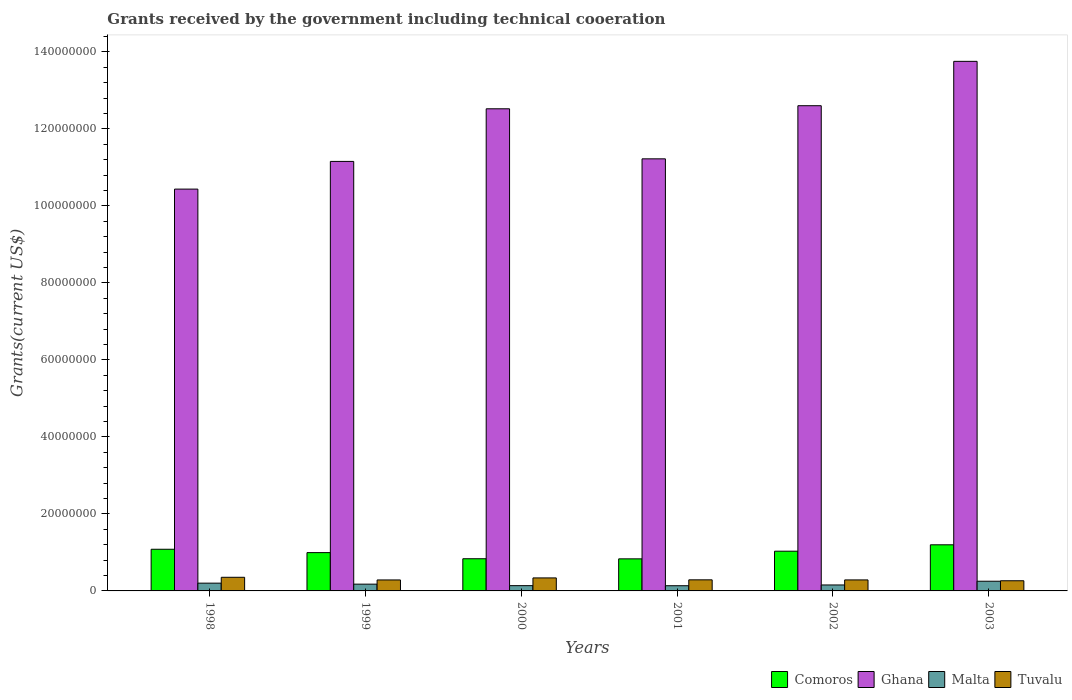How many different coloured bars are there?
Offer a very short reply. 4. How many groups of bars are there?
Ensure brevity in your answer.  6. Are the number of bars per tick equal to the number of legend labels?
Make the answer very short. Yes. How many bars are there on the 6th tick from the left?
Your response must be concise. 4. How many bars are there on the 4th tick from the right?
Give a very brief answer. 4. What is the label of the 3rd group of bars from the left?
Provide a short and direct response. 2000. In how many cases, is the number of bars for a given year not equal to the number of legend labels?
Make the answer very short. 0. What is the total grants received by the government in Comoros in 1998?
Make the answer very short. 1.08e+07. Across all years, what is the maximum total grants received by the government in Comoros?
Offer a very short reply. 1.20e+07. Across all years, what is the minimum total grants received by the government in Tuvalu?
Provide a succinct answer. 2.64e+06. What is the total total grants received by the government in Ghana in the graph?
Your answer should be very brief. 7.17e+08. What is the difference between the total grants received by the government in Tuvalu in 1998 and the total grants received by the government in Ghana in 2001?
Give a very brief answer. -1.09e+08. What is the average total grants received by the government in Comoros per year?
Your answer should be compact. 9.96e+06. In the year 1999, what is the difference between the total grants received by the government in Tuvalu and total grants received by the government in Comoros?
Your answer should be very brief. -7.10e+06. What is the ratio of the total grants received by the government in Malta in 2000 to that in 2002?
Your response must be concise. 0.88. Is the difference between the total grants received by the government in Tuvalu in 1999 and 2003 greater than the difference between the total grants received by the government in Comoros in 1999 and 2003?
Provide a succinct answer. Yes. What is the difference between the highest and the second highest total grants received by the government in Comoros?
Provide a succinct answer. 1.16e+06. In how many years, is the total grants received by the government in Ghana greater than the average total grants received by the government in Ghana taken over all years?
Your answer should be very brief. 3. Is it the case that in every year, the sum of the total grants received by the government in Ghana and total grants received by the government in Tuvalu is greater than the sum of total grants received by the government in Malta and total grants received by the government in Comoros?
Offer a terse response. Yes. What does the 1st bar from the left in 2000 represents?
Offer a very short reply. Comoros. What does the 1st bar from the right in 2003 represents?
Provide a short and direct response. Tuvalu. Is it the case that in every year, the sum of the total grants received by the government in Ghana and total grants received by the government in Tuvalu is greater than the total grants received by the government in Comoros?
Your response must be concise. Yes. What is the difference between two consecutive major ticks on the Y-axis?
Offer a very short reply. 2.00e+07. Are the values on the major ticks of Y-axis written in scientific E-notation?
Keep it short and to the point. No. Does the graph contain any zero values?
Give a very brief answer. No. Does the graph contain grids?
Keep it short and to the point. No. What is the title of the graph?
Make the answer very short. Grants received by the government including technical cooeration. Does "Niger" appear as one of the legend labels in the graph?
Keep it short and to the point. No. What is the label or title of the Y-axis?
Ensure brevity in your answer.  Grants(current US$). What is the Grants(current US$) in Comoros in 1998?
Offer a very short reply. 1.08e+07. What is the Grants(current US$) of Ghana in 1998?
Make the answer very short. 1.04e+08. What is the Grants(current US$) in Malta in 1998?
Your answer should be very brief. 2.02e+06. What is the Grants(current US$) of Tuvalu in 1998?
Ensure brevity in your answer.  3.54e+06. What is the Grants(current US$) of Comoros in 1999?
Your response must be concise. 9.95e+06. What is the Grants(current US$) of Ghana in 1999?
Ensure brevity in your answer.  1.12e+08. What is the Grants(current US$) of Malta in 1999?
Your answer should be very brief. 1.76e+06. What is the Grants(current US$) in Tuvalu in 1999?
Offer a terse response. 2.85e+06. What is the Grants(current US$) in Comoros in 2000?
Ensure brevity in your answer.  8.36e+06. What is the Grants(current US$) in Ghana in 2000?
Make the answer very short. 1.25e+08. What is the Grants(current US$) of Malta in 2000?
Your answer should be very brief. 1.37e+06. What is the Grants(current US$) in Tuvalu in 2000?
Provide a short and direct response. 3.38e+06. What is the Grants(current US$) of Comoros in 2001?
Offer a terse response. 8.33e+06. What is the Grants(current US$) in Ghana in 2001?
Keep it short and to the point. 1.12e+08. What is the Grants(current US$) in Malta in 2001?
Provide a succinct answer. 1.35e+06. What is the Grants(current US$) of Tuvalu in 2001?
Your response must be concise. 2.88e+06. What is the Grants(current US$) in Comoros in 2002?
Ensure brevity in your answer.  1.03e+07. What is the Grants(current US$) in Ghana in 2002?
Give a very brief answer. 1.26e+08. What is the Grants(current US$) of Malta in 2002?
Your answer should be very brief. 1.55e+06. What is the Grants(current US$) in Tuvalu in 2002?
Your response must be concise. 2.86e+06. What is the Grants(current US$) in Comoros in 2003?
Your response must be concise. 1.20e+07. What is the Grants(current US$) in Ghana in 2003?
Give a very brief answer. 1.38e+08. What is the Grants(current US$) of Malta in 2003?
Your answer should be compact. 2.52e+06. What is the Grants(current US$) in Tuvalu in 2003?
Your answer should be compact. 2.64e+06. Across all years, what is the maximum Grants(current US$) in Comoros?
Offer a terse response. 1.20e+07. Across all years, what is the maximum Grants(current US$) of Ghana?
Provide a succinct answer. 1.38e+08. Across all years, what is the maximum Grants(current US$) in Malta?
Ensure brevity in your answer.  2.52e+06. Across all years, what is the maximum Grants(current US$) in Tuvalu?
Offer a terse response. 3.54e+06. Across all years, what is the minimum Grants(current US$) in Comoros?
Make the answer very short. 8.33e+06. Across all years, what is the minimum Grants(current US$) in Ghana?
Keep it short and to the point. 1.04e+08. Across all years, what is the minimum Grants(current US$) of Malta?
Offer a very short reply. 1.35e+06. Across all years, what is the minimum Grants(current US$) of Tuvalu?
Provide a short and direct response. 2.64e+06. What is the total Grants(current US$) of Comoros in the graph?
Offer a very short reply. 5.98e+07. What is the total Grants(current US$) of Ghana in the graph?
Provide a succinct answer. 7.17e+08. What is the total Grants(current US$) in Malta in the graph?
Give a very brief answer. 1.06e+07. What is the total Grants(current US$) in Tuvalu in the graph?
Make the answer very short. 1.82e+07. What is the difference between the Grants(current US$) in Comoros in 1998 and that in 1999?
Ensure brevity in your answer.  8.70e+05. What is the difference between the Grants(current US$) of Ghana in 1998 and that in 1999?
Provide a short and direct response. -7.19e+06. What is the difference between the Grants(current US$) in Malta in 1998 and that in 1999?
Make the answer very short. 2.60e+05. What is the difference between the Grants(current US$) in Tuvalu in 1998 and that in 1999?
Your response must be concise. 6.90e+05. What is the difference between the Grants(current US$) in Comoros in 1998 and that in 2000?
Provide a short and direct response. 2.46e+06. What is the difference between the Grants(current US$) of Ghana in 1998 and that in 2000?
Offer a terse response. -2.09e+07. What is the difference between the Grants(current US$) in Malta in 1998 and that in 2000?
Keep it short and to the point. 6.50e+05. What is the difference between the Grants(current US$) of Comoros in 1998 and that in 2001?
Your answer should be compact. 2.49e+06. What is the difference between the Grants(current US$) of Ghana in 1998 and that in 2001?
Your answer should be very brief. -7.86e+06. What is the difference between the Grants(current US$) in Malta in 1998 and that in 2001?
Ensure brevity in your answer.  6.70e+05. What is the difference between the Grants(current US$) of Comoros in 1998 and that in 2002?
Your answer should be compact. 5.00e+05. What is the difference between the Grants(current US$) in Ghana in 1998 and that in 2002?
Your answer should be compact. -2.17e+07. What is the difference between the Grants(current US$) in Tuvalu in 1998 and that in 2002?
Keep it short and to the point. 6.80e+05. What is the difference between the Grants(current US$) in Comoros in 1998 and that in 2003?
Your answer should be compact. -1.16e+06. What is the difference between the Grants(current US$) of Ghana in 1998 and that in 2003?
Offer a very short reply. -3.32e+07. What is the difference between the Grants(current US$) of Malta in 1998 and that in 2003?
Offer a terse response. -5.00e+05. What is the difference between the Grants(current US$) in Tuvalu in 1998 and that in 2003?
Give a very brief answer. 9.00e+05. What is the difference between the Grants(current US$) of Comoros in 1999 and that in 2000?
Your answer should be compact. 1.59e+06. What is the difference between the Grants(current US$) in Ghana in 1999 and that in 2000?
Ensure brevity in your answer.  -1.37e+07. What is the difference between the Grants(current US$) in Tuvalu in 1999 and that in 2000?
Offer a very short reply. -5.30e+05. What is the difference between the Grants(current US$) in Comoros in 1999 and that in 2001?
Your answer should be very brief. 1.62e+06. What is the difference between the Grants(current US$) of Ghana in 1999 and that in 2001?
Offer a very short reply. -6.70e+05. What is the difference between the Grants(current US$) in Tuvalu in 1999 and that in 2001?
Provide a succinct answer. -3.00e+04. What is the difference between the Grants(current US$) in Comoros in 1999 and that in 2002?
Offer a very short reply. -3.70e+05. What is the difference between the Grants(current US$) in Ghana in 1999 and that in 2002?
Your answer should be compact. -1.45e+07. What is the difference between the Grants(current US$) in Tuvalu in 1999 and that in 2002?
Make the answer very short. -10000. What is the difference between the Grants(current US$) of Comoros in 1999 and that in 2003?
Your answer should be very brief. -2.03e+06. What is the difference between the Grants(current US$) of Ghana in 1999 and that in 2003?
Ensure brevity in your answer.  -2.60e+07. What is the difference between the Grants(current US$) in Malta in 1999 and that in 2003?
Offer a terse response. -7.60e+05. What is the difference between the Grants(current US$) in Tuvalu in 1999 and that in 2003?
Provide a succinct answer. 2.10e+05. What is the difference between the Grants(current US$) of Ghana in 2000 and that in 2001?
Provide a succinct answer. 1.30e+07. What is the difference between the Grants(current US$) of Malta in 2000 and that in 2001?
Give a very brief answer. 2.00e+04. What is the difference between the Grants(current US$) in Comoros in 2000 and that in 2002?
Your answer should be compact. -1.96e+06. What is the difference between the Grants(current US$) of Ghana in 2000 and that in 2002?
Provide a succinct answer. -8.00e+05. What is the difference between the Grants(current US$) in Tuvalu in 2000 and that in 2002?
Offer a very short reply. 5.20e+05. What is the difference between the Grants(current US$) in Comoros in 2000 and that in 2003?
Give a very brief answer. -3.62e+06. What is the difference between the Grants(current US$) in Ghana in 2000 and that in 2003?
Provide a short and direct response. -1.23e+07. What is the difference between the Grants(current US$) in Malta in 2000 and that in 2003?
Your response must be concise. -1.15e+06. What is the difference between the Grants(current US$) of Tuvalu in 2000 and that in 2003?
Provide a succinct answer. 7.40e+05. What is the difference between the Grants(current US$) in Comoros in 2001 and that in 2002?
Give a very brief answer. -1.99e+06. What is the difference between the Grants(current US$) of Ghana in 2001 and that in 2002?
Ensure brevity in your answer.  -1.38e+07. What is the difference between the Grants(current US$) of Tuvalu in 2001 and that in 2002?
Provide a succinct answer. 2.00e+04. What is the difference between the Grants(current US$) of Comoros in 2001 and that in 2003?
Keep it short and to the point. -3.65e+06. What is the difference between the Grants(current US$) of Ghana in 2001 and that in 2003?
Give a very brief answer. -2.53e+07. What is the difference between the Grants(current US$) in Malta in 2001 and that in 2003?
Offer a terse response. -1.17e+06. What is the difference between the Grants(current US$) in Comoros in 2002 and that in 2003?
Offer a terse response. -1.66e+06. What is the difference between the Grants(current US$) in Ghana in 2002 and that in 2003?
Your answer should be very brief. -1.15e+07. What is the difference between the Grants(current US$) of Malta in 2002 and that in 2003?
Provide a short and direct response. -9.70e+05. What is the difference between the Grants(current US$) of Comoros in 1998 and the Grants(current US$) of Ghana in 1999?
Your response must be concise. -1.01e+08. What is the difference between the Grants(current US$) of Comoros in 1998 and the Grants(current US$) of Malta in 1999?
Offer a very short reply. 9.06e+06. What is the difference between the Grants(current US$) of Comoros in 1998 and the Grants(current US$) of Tuvalu in 1999?
Give a very brief answer. 7.97e+06. What is the difference between the Grants(current US$) of Ghana in 1998 and the Grants(current US$) of Malta in 1999?
Your answer should be very brief. 1.03e+08. What is the difference between the Grants(current US$) of Ghana in 1998 and the Grants(current US$) of Tuvalu in 1999?
Provide a short and direct response. 1.02e+08. What is the difference between the Grants(current US$) of Malta in 1998 and the Grants(current US$) of Tuvalu in 1999?
Offer a terse response. -8.30e+05. What is the difference between the Grants(current US$) in Comoros in 1998 and the Grants(current US$) in Ghana in 2000?
Make the answer very short. -1.14e+08. What is the difference between the Grants(current US$) in Comoros in 1998 and the Grants(current US$) in Malta in 2000?
Provide a short and direct response. 9.45e+06. What is the difference between the Grants(current US$) of Comoros in 1998 and the Grants(current US$) of Tuvalu in 2000?
Your answer should be compact. 7.44e+06. What is the difference between the Grants(current US$) of Ghana in 1998 and the Grants(current US$) of Malta in 2000?
Provide a succinct answer. 1.03e+08. What is the difference between the Grants(current US$) of Ghana in 1998 and the Grants(current US$) of Tuvalu in 2000?
Your answer should be compact. 1.01e+08. What is the difference between the Grants(current US$) of Malta in 1998 and the Grants(current US$) of Tuvalu in 2000?
Your answer should be compact. -1.36e+06. What is the difference between the Grants(current US$) of Comoros in 1998 and the Grants(current US$) of Ghana in 2001?
Offer a terse response. -1.01e+08. What is the difference between the Grants(current US$) in Comoros in 1998 and the Grants(current US$) in Malta in 2001?
Give a very brief answer. 9.47e+06. What is the difference between the Grants(current US$) in Comoros in 1998 and the Grants(current US$) in Tuvalu in 2001?
Offer a terse response. 7.94e+06. What is the difference between the Grants(current US$) in Ghana in 1998 and the Grants(current US$) in Malta in 2001?
Offer a terse response. 1.03e+08. What is the difference between the Grants(current US$) in Ghana in 1998 and the Grants(current US$) in Tuvalu in 2001?
Your answer should be compact. 1.01e+08. What is the difference between the Grants(current US$) in Malta in 1998 and the Grants(current US$) in Tuvalu in 2001?
Your answer should be very brief. -8.60e+05. What is the difference between the Grants(current US$) of Comoros in 1998 and the Grants(current US$) of Ghana in 2002?
Provide a succinct answer. -1.15e+08. What is the difference between the Grants(current US$) in Comoros in 1998 and the Grants(current US$) in Malta in 2002?
Make the answer very short. 9.27e+06. What is the difference between the Grants(current US$) in Comoros in 1998 and the Grants(current US$) in Tuvalu in 2002?
Your response must be concise. 7.96e+06. What is the difference between the Grants(current US$) of Ghana in 1998 and the Grants(current US$) of Malta in 2002?
Provide a succinct answer. 1.03e+08. What is the difference between the Grants(current US$) in Ghana in 1998 and the Grants(current US$) in Tuvalu in 2002?
Your answer should be compact. 1.02e+08. What is the difference between the Grants(current US$) in Malta in 1998 and the Grants(current US$) in Tuvalu in 2002?
Provide a short and direct response. -8.40e+05. What is the difference between the Grants(current US$) in Comoros in 1998 and the Grants(current US$) in Ghana in 2003?
Give a very brief answer. -1.27e+08. What is the difference between the Grants(current US$) of Comoros in 1998 and the Grants(current US$) of Malta in 2003?
Your answer should be very brief. 8.30e+06. What is the difference between the Grants(current US$) in Comoros in 1998 and the Grants(current US$) in Tuvalu in 2003?
Make the answer very short. 8.18e+06. What is the difference between the Grants(current US$) in Ghana in 1998 and the Grants(current US$) in Malta in 2003?
Offer a terse response. 1.02e+08. What is the difference between the Grants(current US$) of Ghana in 1998 and the Grants(current US$) of Tuvalu in 2003?
Ensure brevity in your answer.  1.02e+08. What is the difference between the Grants(current US$) in Malta in 1998 and the Grants(current US$) in Tuvalu in 2003?
Provide a succinct answer. -6.20e+05. What is the difference between the Grants(current US$) in Comoros in 1999 and the Grants(current US$) in Ghana in 2000?
Offer a very short reply. -1.15e+08. What is the difference between the Grants(current US$) of Comoros in 1999 and the Grants(current US$) of Malta in 2000?
Your answer should be compact. 8.58e+06. What is the difference between the Grants(current US$) in Comoros in 1999 and the Grants(current US$) in Tuvalu in 2000?
Offer a very short reply. 6.57e+06. What is the difference between the Grants(current US$) of Ghana in 1999 and the Grants(current US$) of Malta in 2000?
Provide a succinct answer. 1.10e+08. What is the difference between the Grants(current US$) of Ghana in 1999 and the Grants(current US$) of Tuvalu in 2000?
Give a very brief answer. 1.08e+08. What is the difference between the Grants(current US$) of Malta in 1999 and the Grants(current US$) of Tuvalu in 2000?
Provide a succinct answer. -1.62e+06. What is the difference between the Grants(current US$) in Comoros in 1999 and the Grants(current US$) in Ghana in 2001?
Give a very brief answer. -1.02e+08. What is the difference between the Grants(current US$) of Comoros in 1999 and the Grants(current US$) of Malta in 2001?
Provide a succinct answer. 8.60e+06. What is the difference between the Grants(current US$) in Comoros in 1999 and the Grants(current US$) in Tuvalu in 2001?
Your response must be concise. 7.07e+06. What is the difference between the Grants(current US$) in Ghana in 1999 and the Grants(current US$) in Malta in 2001?
Offer a very short reply. 1.10e+08. What is the difference between the Grants(current US$) of Ghana in 1999 and the Grants(current US$) of Tuvalu in 2001?
Your response must be concise. 1.09e+08. What is the difference between the Grants(current US$) of Malta in 1999 and the Grants(current US$) of Tuvalu in 2001?
Provide a short and direct response. -1.12e+06. What is the difference between the Grants(current US$) of Comoros in 1999 and the Grants(current US$) of Ghana in 2002?
Your answer should be compact. -1.16e+08. What is the difference between the Grants(current US$) of Comoros in 1999 and the Grants(current US$) of Malta in 2002?
Offer a terse response. 8.40e+06. What is the difference between the Grants(current US$) in Comoros in 1999 and the Grants(current US$) in Tuvalu in 2002?
Your answer should be very brief. 7.09e+06. What is the difference between the Grants(current US$) in Ghana in 1999 and the Grants(current US$) in Malta in 2002?
Your answer should be compact. 1.10e+08. What is the difference between the Grants(current US$) of Ghana in 1999 and the Grants(current US$) of Tuvalu in 2002?
Provide a short and direct response. 1.09e+08. What is the difference between the Grants(current US$) of Malta in 1999 and the Grants(current US$) of Tuvalu in 2002?
Offer a terse response. -1.10e+06. What is the difference between the Grants(current US$) of Comoros in 1999 and the Grants(current US$) of Ghana in 2003?
Ensure brevity in your answer.  -1.28e+08. What is the difference between the Grants(current US$) of Comoros in 1999 and the Grants(current US$) of Malta in 2003?
Offer a terse response. 7.43e+06. What is the difference between the Grants(current US$) of Comoros in 1999 and the Grants(current US$) of Tuvalu in 2003?
Ensure brevity in your answer.  7.31e+06. What is the difference between the Grants(current US$) in Ghana in 1999 and the Grants(current US$) in Malta in 2003?
Keep it short and to the point. 1.09e+08. What is the difference between the Grants(current US$) in Ghana in 1999 and the Grants(current US$) in Tuvalu in 2003?
Offer a very short reply. 1.09e+08. What is the difference between the Grants(current US$) of Malta in 1999 and the Grants(current US$) of Tuvalu in 2003?
Provide a succinct answer. -8.80e+05. What is the difference between the Grants(current US$) of Comoros in 2000 and the Grants(current US$) of Ghana in 2001?
Your answer should be compact. -1.04e+08. What is the difference between the Grants(current US$) of Comoros in 2000 and the Grants(current US$) of Malta in 2001?
Ensure brevity in your answer.  7.01e+06. What is the difference between the Grants(current US$) of Comoros in 2000 and the Grants(current US$) of Tuvalu in 2001?
Your response must be concise. 5.48e+06. What is the difference between the Grants(current US$) in Ghana in 2000 and the Grants(current US$) in Malta in 2001?
Offer a very short reply. 1.24e+08. What is the difference between the Grants(current US$) of Ghana in 2000 and the Grants(current US$) of Tuvalu in 2001?
Provide a short and direct response. 1.22e+08. What is the difference between the Grants(current US$) of Malta in 2000 and the Grants(current US$) of Tuvalu in 2001?
Provide a succinct answer. -1.51e+06. What is the difference between the Grants(current US$) in Comoros in 2000 and the Grants(current US$) in Ghana in 2002?
Give a very brief answer. -1.18e+08. What is the difference between the Grants(current US$) in Comoros in 2000 and the Grants(current US$) in Malta in 2002?
Make the answer very short. 6.81e+06. What is the difference between the Grants(current US$) of Comoros in 2000 and the Grants(current US$) of Tuvalu in 2002?
Ensure brevity in your answer.  5.50e+06. What is the difference between the Grants(current US$) in Ghana in 2000 and the Grants(current US$) in Malta in 2002?
Provide a short and direct response. 1.24e+08. What is the difference between the Grants(current US$) in Ghana in 2000 and the Grants(current US$) in Tuvalu in 2002?
Offer a very short reply. 1.22e+08. What is the difference between the Grants(current US$) of Malta in 2000 and the Grants(current US$) of Tuvalu in 2002?
Your answer should be very brief. -1.49e+06. What is the difference between the Grants(current US$) of Comoros in 2000 and the Grants(current US$) of Ghana in 2003?
Your answer should be very brief. -1.29e+08. What is the difference between the Grants(current US$) in Comoros in 2000 and the Grants(current US$) in Malta in 2003?
Your answer should be compact. 5.84e+06. What is the difference between the Grants(current US$) of Comoros in 2000 and the Grants(current US$) of Tuvalu in 2003?
Provide a short and direct response. 5.72e+06. What is the difference between the Grants(current US$) of Ghana in 2000 and the Grants(current US$) of Malta in 2003?
Give a very brief answer. 1.23e+08. What is the difference between the Grants(current US$) of Ghana in 2000 and the Grants(current US$) of Tuvalu in 2003?
Provide a succinct answer. 1.23e+08. What is the difference between the Grants(current US$) of Malta in 2000 and the Grants(current US$) of Tuvalu in 2003?
Give a very brief answer. -1.27e+06. What is the difference between the Grants(current US$) in Comoros in 2001 and the Grants(current US$) in Ghana in 2002?
Offer a terse response. -1.18e+08. What is the difference between the Grants(current US$) in Comoros in 2001 and the Grants(current US$) in Malta in 2002?
Your answer should be very brief. 6.78e+06. What is the difference between the Grants(current US$) in Comoros in 2001 and the Grants(current US$) in Tuvalu in 2002?
Offer a terse response. 5.47e+06. What is the difference between the Grants(current US$) of Ghana in 2001 and the Grants(current US$) of Malta in 2002?
Your answer should be very brief. 1.11e+08. What is the difference between the Grants(current US$) of Ghana in 2001 and the Grants(current US$) of Tuvalu in 2002?
Give a very brief answer. 1.09e+08. What is the difference between the Grants(current US$) of Malta in 2001 and the Grants(current US$) of Tuvalu in 2002?
Your answer should be very brief. -1.51e+06. What is the difference between the Grants(current US$) in Comoros in 2001 and the Grants(current US$) in Ghana in 2003?
Provide a succinct answer. -1.29e+08. What is the difference between the Grants(current US$) of Comoros in 2001 and the Grants(current US$) of Malta in 2003?
Your response must be concise. 5.81e+06. What is the difference between the Grants(current US$) in Comoros in 2001 and the Grants(current US$) in Tuvalu in 2003?
Offer a terse response. 5.69e+06. What is the difference between the Grants(current US$) of Ghana in 2001 and the Grants(current US$) of Malta in 2003?
Your answer should be very brief. 1.10e+08. What is the difference between the Grants(current US$) in Ghana in 2001 and the Grants(current US$) in Tuvalu in 2003?
Provide a short and direct response. 1.10e+08. What is the difference between the Grants(current US$) of Malta in 2001 and the Grants(current US$) of Tuvalu in 2003?
Make the answer very short. -1.29e+06. What is the difference between the Grants(current US$) of Comoros in 2002 and the Grants(current US$) of Ghana in 2003?
Provide a short and direct response. -1.27e+08. What is the difference between the Grants(current US$) in Comoros in 2002 and the Grants(current US$) in Malta in 2003?
Keep it short and to the point. 7.80e+06. What is the difference between the Grants(current US$) of Comoros in 2002 and the Grants(current US$) of Tuvalu in 2003?
Ensure brevity in your answer.  7.68e+06. What is the difference between the Grants(current US$) in Ghana in 2002 and the Grants(current US$) in Malta in 2003?
Make the answer very short. 1.24e+08. What is the difference between the Grants(current US$) of Ghana in 2002 and the Grants(current US$) of Tuvalu in 2003?
Provide a short and direct response. 1.23e+08. What is the difference between the Grants(current US$) in Malta in 2002 and the Grants(current US$) in Tuvalu in 2003?
Ensure brevity in your answer.  -1.09e+06. What is the average Grants(current US$) of Comoros per year?
Offer a terse response. 9.96e+06. What is the average Grants(current US$) of Ghana per year?
Give a very brief answer. 1.19e+08. What is the average Grants(current US$) of Malta per year?
Keep it short and to the point. 1.76e+06. What is the average Grants(current US$) of Tuvalu per year?
Your response must be concise. 3.02e+06. In the year 1998, what is the difference between the Grants(current US$) of Comoros and Grants(current US$) of Ghana?
Make the answer very short. -9.36e+07. In the year 1998, what is the difference between the Grants(current US$) in Comoros and Grants(current US$) in Malta?
Keep it short and to the point. 8.80e+06. In the year 1998, what is the difference between the Grants(current US$) in Comoros and Grants(current US$) in Tuvalu?
Your response must be concise. 7.28e+06. In the year 1998, what is the difference between the Grants(current US$) of Ghana and Grants(current US$) of Malta?
Ensure brevity in your answer.  1.02e+08. In the year 1998, what is the difference between the Grants(current US$) of Ghana and Grants(current US$) of Tuvalu?
Make the answer very short. 1.01e+08. In the year 1998, what is the difference between the Grants(current US$) of Malta and Grants(current US$) of Tuvalu?
Your response must be concise. -1.52e+06. In the year 1999, what is the difference between the Grants(current US$) of Comoros and Grants(current US$) of Ghana?
Make the answer very short. -1.02e+08. In the year 1999, what is the difference between the Grants(current US$) of Comoros and Grants(current US$) of Malta?
Provide a short and direct response. 8.19e+06. In the year 1999, what is the difference between the Grants(current US$) of Comoros and Grants(current US$) of Tuvalu?
Keep it short and to the point. 7.10e+06. In the year 1999, what is the difference between the Grants(current US$) of Ghana and Grants(current US$) of Malta?
Provide a short and direct response. 1.10e+08. In the year 1999, what is the difference between the Grants(current US$) of Ghana and Grants(current US$) of Tuvalu?
Offer a very short reply. 1.09e+08. In the year 1999, what is the difference between the Grants(current US$) in Malta and Grants(current US$) in Tuvalu?
Your answer should be compact. -1.09e+06. In the year 2000, what is the difference between the Grants(current US$) of Comoros and Grants(current US$) of Ghana?
Give a very brief answer. -1.17e+08. In the year 2000, what is the difference between the Grants(current US$) of Comoros and Grants(current US$) of Malta?
Provide a succinct answer. 6.99e+06. In the year 2000, what is the difference between the Grants(current US$) of Comoros and Grants(current US$) of Tuvalu?
Your response must be concise. 4.98e+06. In the year 2000, what is the difference between the Grants(current US$) of Ghana and Grants(current US$) of Malta?
Your response must be concise. 1.24e+08. In the year 2000, what is the difference between the Grants(current US$) of Ghana and Grants(current US$) of Tuvalu?
Make the answer very short. 1.22e+08. In the year 2000, what is the difference between the Grants(current US$) of Malta and Grants(current US$) of Tuvalu?
Offer a terse response. -2.01e+06. In the year 2001, what is the difference between the Grants(current US$) in Comoros and Grants(current US$) in Ghana?
Offer a terse response. -1.04e+08. In the year 2001, what is the difference between the Grants(current US$) in Comoros and Grants(current US$) in Malta?
Your answer should be compact. 6.98e+06. In the year 2001, what is the difference between the Grants(current US$) in Comoros and Grants(current US$) in Tuvalu?
Provide a short and direct response. 5.45e+06. In the year 2001, what is the difference between the Grants(current US$) in Ghana and Grants(current US$) in Malta?
Offer a terse response. 1.11e+08. In the year 2001, what is the difference between the Grants(current US$) of Ghana and Grants(current US$) of Tuvalu?
Provide a succinct answer. 1.09e+08. In the year 2001, what is the difference between the Grants(current US$) of Malta and Grants(current US$) of Tuvalu?
Your answer should be compact. -1.53e+06. In the year 2002, what is the difference between the Grants(current US$) of Comoros and Grants(current US$) of Ghana?
Your response must be concise. -1.16e+08. In the year 2002, what is the difference between the Grants(current US$) in Comoros and Grants(current US$) in Malta?
Provide a succinct answer. 8.77e+06. In the year 2002, what is the difference between the Grants(current US$) of Comoros and Grants(current US$) of Tuvalu?
Make the answer very short. 7.46e+06. In the year 2002, what is the difference between the Grants(current US$) in Ghana and Grants(current US$) in Malta?
Offer a very short reply. 1.24e+08. In the year 2002, what is the difference between the Grants(current US$) of Ghana and Grants(current US$) of Tuvalu?
Offer a terse response. 1.23e+08. In the year 2002, what is the difference between the Grants(current US$) of Malta and Grants(current US$) of Tuvalu?
Ensure brevity in your answer.  -1.31e+06. In the year 2003, what is the difference between the Grants(current US$) in Comoros and Grants(current US$) in Ghana?
Offer a terse response. -1.26e+08. In the year 2003, what is the difference between the Grants(current US$) in Comoros and Grants(current US$) in Malta?
Provide a succinct answer. 9.46e+06. In the year 2003, what is the difference between the Grants(current US$) in Comoros and Grants(current US$) in Tuvalu?
Give a very brief answer. 9.34e+06. In the year 2003, what is the difference between the Grants(current US$) of Ghana and Grants(current US$) of Malta?
Ensure brevity in your answer.  1.35e+08. In the year 2003, what is the difference between the Grants(current US$) of Ghana and Grants(current US$) of Tuvalu?
Make the answer very short. 1.35e+08. In the year 2003, what is the difference between the Grants(current US$) of Malta and Grants(current US$) of Tuvalu?
Your answer should be very brief. -1.20e+05. What is the ratio of the Grants(current US$) of Comoros in 1998 to that in 1999?
Your response must be concise. 1.09. What is the ratio of the Grants(current US$) of Ghana in 1998 to that in 1999?
Provide a short and direct response. 0.94. What is the ratio of the Grants(current US$) of Malta in 1998 to that in 1999?
Provide a short and direct response. 1.15. What is the ratio of the Grants(current US$) of Tuvalu in 1998 to that in 1999?
Give a very brief answer. 1.24. What is the ratio of the Grants(current US$) of Comoros in 1998 to that in 2000?
Ensure brevity in your answer.  1.29. What is the ratio of the Grants(current US$) in Ghana in 1998 to that in 2000?
Provide a succinct answer. 0.83. What is the ratio of the Grants(current US$) in Malta in 1998 to that in 2000?
Provide a short and direct response. 1.47. What is the ratio of the Grants(current US$) in Tuvalu in 1998 to that in 2000?
Make the answer very short. 1.05. What is the ratio of the Grants(current US$) in Comoros in 1998 to that in 2001?
Make the answer very short. 1.3. What is the ratio of the Grants(current US$) in Ghana in 1998 to that in 2001?
Your response must be concise. 0.93. What is the ratio of the Grants(current US$) in Malta in 1998 to that in 2001?
Your response must be concise. 1.5. What is the ratio of the Grants(current US$) of Tuvalu in 1998 to that in 2001?
Offer a very short reply. 1.23. What is the ratio of the Grants(current US$) of Comoros in 1998 to that in 2002?
Offer a terse response. 1.05. What is the ratio of the Grants(current US$) in Ghana in 1998 to that in 2002?
Your answer should be very brief. 0.83. What is the ratio of the Grants(current US$) in Malta in 1998 to that in 2002?
Your answer should be compact. 1.3. What is the ratio of the Grants(current US$) in Tuvalu in 1998 to that in 2002?
Your answer should be very brief. 1.24. What is the ratio of the Grants(current US$) in Comoros in 1998 to that in 2003?
Give a very brief answer. 0.9. What is the ratio of the Grants(current US$) in Ghana in 1998 to that in 2003?
Offer a terse response. 0.76. What is the ratio of the Grants(current US$) of Malta in 1998 to that in 2003?
Provide a short and direct response. 0.8. What is the ratio of the Grants(current US$) of Tuvalu in 1998 to that in 2003?
Offer a terse response. 1.34. What is the ratio of the Grants(current US$) in Comoros in 1999 to that in 2000?
Make the answer very short. 1.19. What is the ratio of the Grants(current US$) in Ghana in 1999 to that in 2000?
Your answer should be very brief. 0.89. What is the ratio of the Grants(current US$) in Malta in 1999 to that in 2000?
Make the answer very short. 1.28. What is the ratio of the Grants(current US$) in Tuvalu in 1999 to that in 2000?
Provide a short and direct response. 0.84. What is the ratio of the Grants(current US$) in Comoros in 1999 to that in 2001?
Keep it short and to the point. 1.19. What is the ratio of the Grants(current US$) of Ghana in 1999 to that in 2001?
Provide a succinct answer. 0.99. What is the ratio of the Grants(current US$) of Malta in 1999 to that in 2001?
Provide a short and direct response. 1.3. What is the ratio of the Grants(current US$) of Tuvalu in 1999 to that in 2001?
Provide a short and direct response. 0.99. What is the ratio of the Grants(current US$) in Comoros in 1999 to that in 2002?
Ensure brevity in your answer.  0.96. What is the ratio of the Grants(current US$) of Ghana in 1999 to that in 2002?
Make the answer very short. 0.89. What is the ratio of the Grants(current US$) in Malta in 1999 to that in 2002?
Offer a terse response. 1.14. What is the ratio of the Grants(current US$) of Comoros in 1999 to that in 2003?
Offer a terse response. 0.83. What is the ratio of the Grants(current US$) in Ghana in 1999 to that in 2003?
Ensure brevity in your answer.  0.81. What is the ratio of the Grants(current US$) of Malta in 1999 to that in 2003?
Your answer should be compact. 0.7. What is the ratio of the Grants(current US$) in Tuvalu in 1999 to that in 2003?
Make the answer very short. 1.08. What is the ratio of the Grants(current US$) in Ghana in 2000 to that in 2001?
Your response must be concise. 1.12. What is the ratio of the Grants(current US$) in Malta in 2000 to that in 2001?
Your answer should be compact. 1.01. What is the ratio of the Grants(current US$) of Tuvalu in 2000 to that in 2001?
Give a very brief answer. 1.17. What is the ratio of the Grants(current US$) of Comoros in 2000 to that in 2002?
Give a very brief answer. 0.81. What is the ratio of the Grants(current US$) of Malta in 2000 to that in 2002?
Your response must be concise. 0.88. What is the ratio of the Grants(current US$) in Tuvalu in 2000 to that in 2002?
Provide a short and direct response. 1.18. What is the ratio of the Grants(current US$) of Comoros in 2000 to that in 2003?
Offer a very short reply. 0.7. What is the ratio of the Grants(current US$) of Ghana in 2000 to that in 2003?
Your answer should be very brief. 0.91. What is the ratio of the Grants(current US$) in Malta in 2000 to that in 2003?
Your answer should be compact. 0.54. What is the ratio of the Grants(current US$) of Tuvalu in 2000 to that in 2003?
Provide a short and direct response. 1.28. What is the ratio of the Grants(current US$) of Comoros in 2001 to that in 2002?
Ensure brevity in your answer.  0.81. What is the ratio of the Grants(current US$) in Ghana in 2001 to that in 2002?
Provide a short and direct response. 0.89. What is the ratio of the Grants(current US$) of Malta in 2001 to that in 2002?
Give a very brief answer. 0.87. What is the ratio of the Grants(current US$) in Comoros in 2001 to that in 2003?
Your answer should be compact. 0.7. What is the ratio of the Grants(current US$) of Ghana in 2001 to that in 2003?
Provide a succinct answer. 0.82. What is the ratio of the Grants(current US$) of Malta in 2001 to that in 2003?
Your answer should be compact. 0.54. What is the ratio of the Grants(current US$) of Tuvalu in 2001 to that in 2003?
Your answer should be compact. 1.09. What is the ratio of the Grants(current US$) of Comoros in 2002 to that in 2003?
Your answer should be very brief. 0.86. What is the ratio of the Grants(current US$) of Ghana in 2002 to that in 2003?
Your answer should be very brief. 0.92. What is the ratio of the Grants(current US$) of Malta in 2002 to that in 2003?
Your answer should be compact. 0.62. What is the ratio of the Grants(current US$) of Tuvalu in 2002 to that in 2003?
Offer a terse response. 1.08. What is the difference between the highest and the second highest Grants(current US$) of Comoros?
Your answer should be very brief. 1.16e+06. What is the difference between the highest and the second highest Grants(current US$) of Ghana?
Make the answer very short. 1.15e+07. What is the difference between the highest and the second highest Grants(current US$) in Malta?
Offer a very short reply. 5.00e+05. What is the difference between the highest and the second highest Grants(current US$) in Tuvalu?
Provide a short and direct response. 1.60e+05. What is the difference between the highest and the lowest Grants(current US$) in Comoros?
Your response must be concise. 3.65e+06. What is the difference between the highest and the lowest Grants(current US$) of Ghana?
Make the answer very short. 3.32e+07. What is the difference between the highest and the lowest Grants(current US$) in Malta?
Your answer should be compact. 1.17e+06. 